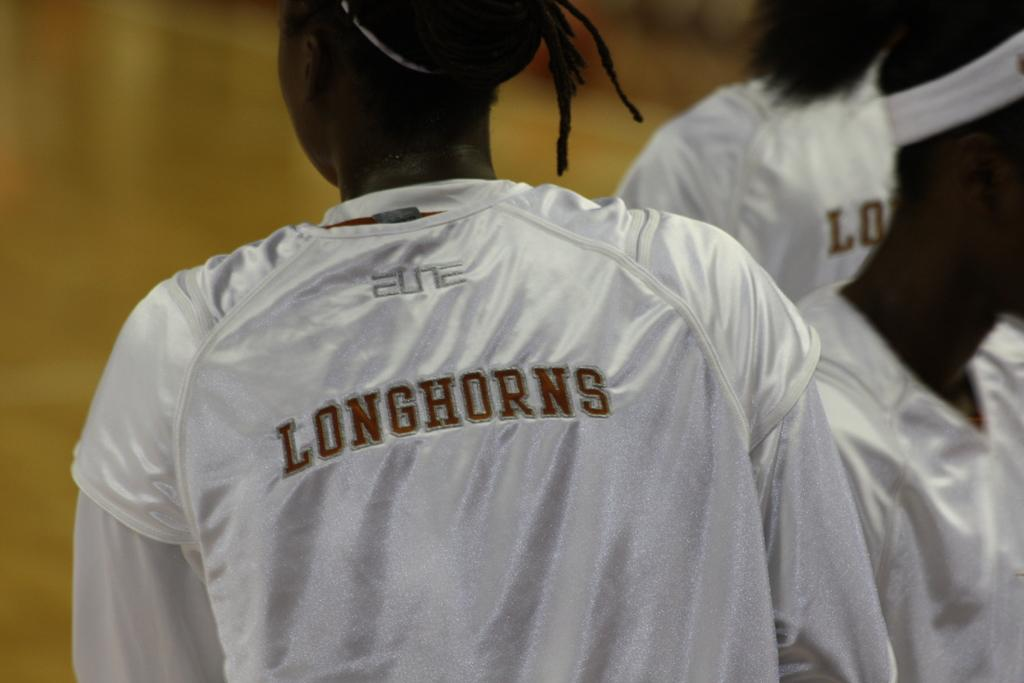How many people are present in the image? There are three people in the image. What are the people wearing in the image? Each person is wearing a white color jacket. What statement does the person in the middle make in the image? There is no dialogue or statements present in the image, so it cannot be determined what the person in the middle might say. 